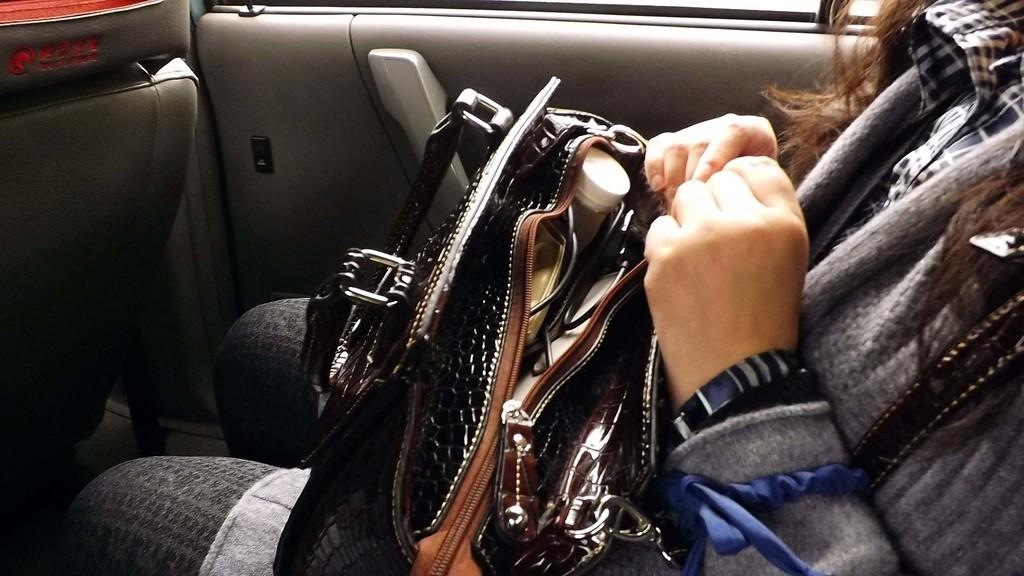Who is present in the image? There is a woman in the image. What is the woman wearing around her neck? The woman is wearing a scarf. What is the woman holding in her hand? The woman is holding a bag. What can be found inside the bag? The bag contains a cable and other things. What feature is present on the door in the image? There is a door with a handle in the image. Can you see a knife being used by the woman in the image? No, there is no knife present in the image. What type of thrill can be experienced by the woman in the image? The image does not provide any information about the woman experiencing a thrill. 